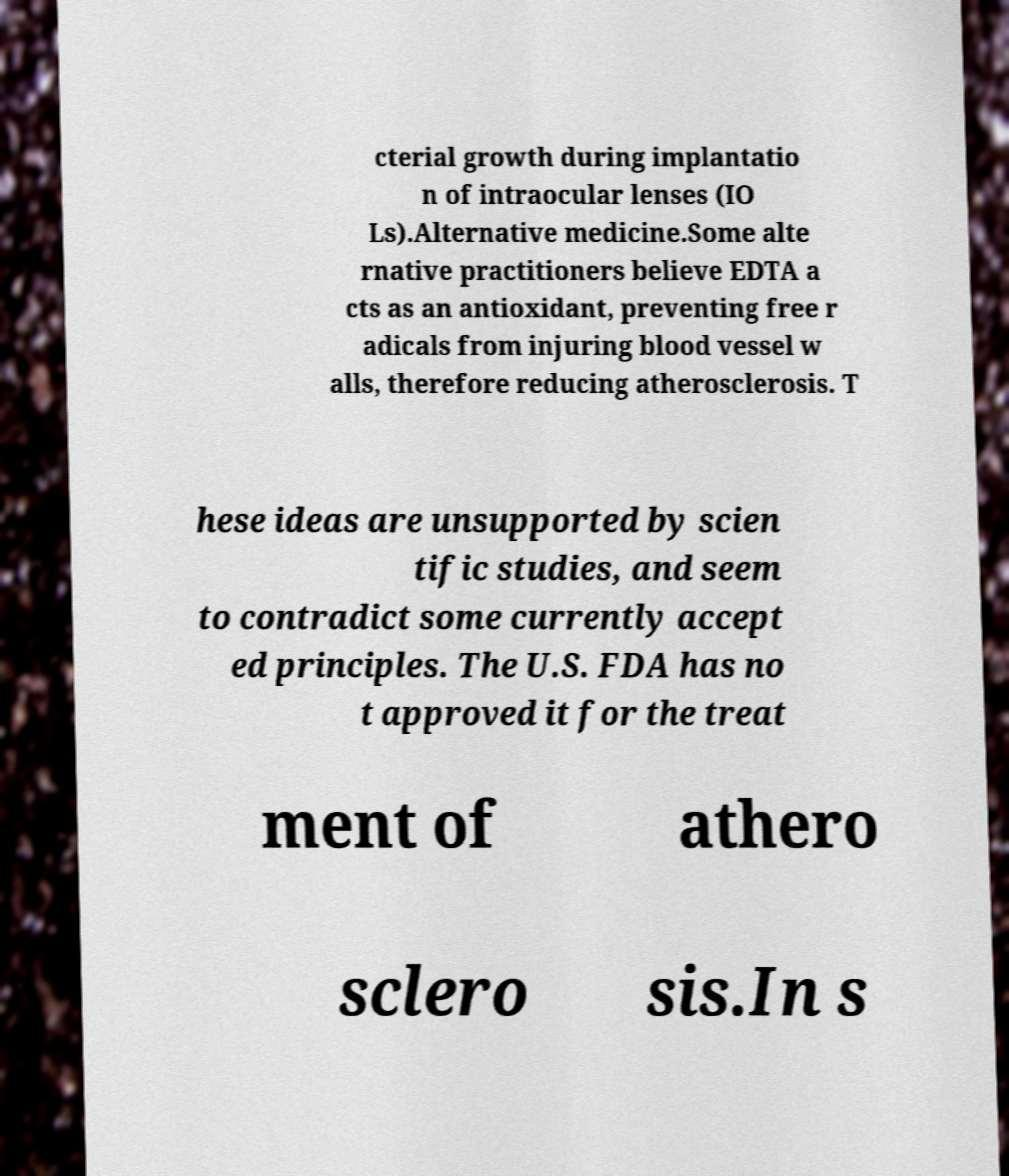Could you assist in decoding the text presented in this image and type it out clearly? cterial growth during implantatio n of intraocular lenses (IO Ls).Alternative medicine.Some alte rnative practitioners believe EDTA a cts as an antioxidant, preventing free r adicals from injuring blood vessel w alls, therefore reducing atherosclerosis. T hese ideas are unsupported by scien tific studies, and seem to contradict some currently accept ed principles. The U.S. FDA has no t approved it for the treat ment of athero sclero sis.In s 